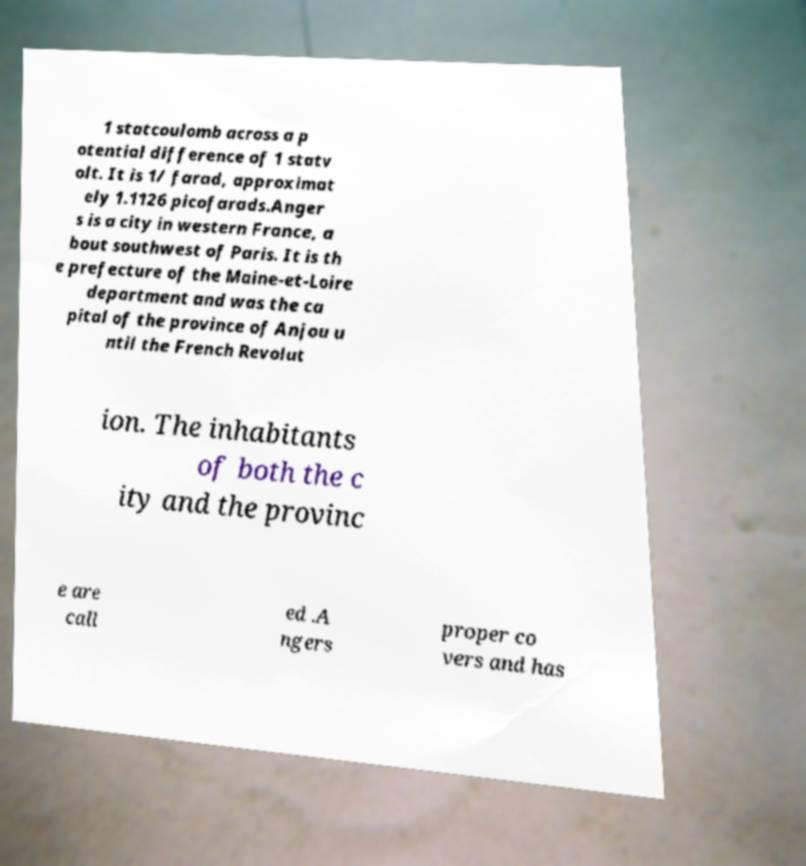Can you accurately transcribe the text from the provided image for me? 1 statcoulomb across a p otential difference of 1 statv olt. It is 1/ farad, approximat ely 1.1126 picofarads.Anger s is a city in western France, a bout southwest of Paris. It is th e prefecture of the Maine-et-Loire department and was the ca pital of the province of Anjou u ntil the French Revolut ion. The inhabitants of both the c ity and the provinc e are call ed .A ngers proper co vers and has 